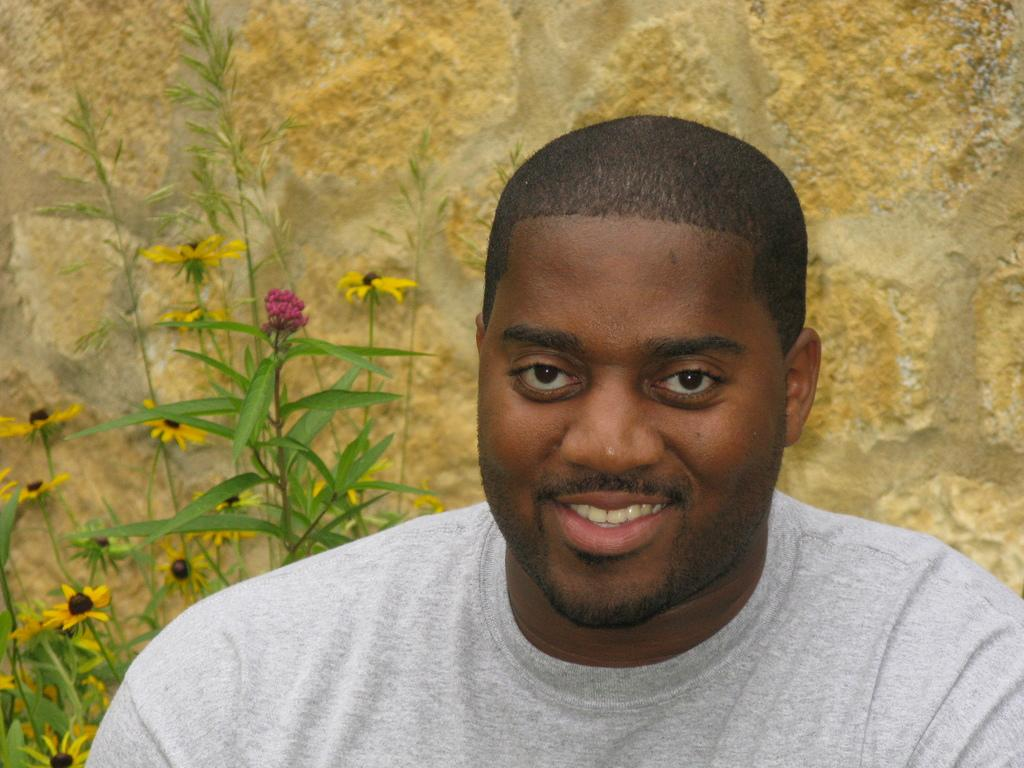Who is present in the image? There is a man in the image. What is the man doing in the image? The man is smiling in the image. What is the man wearing in the image? The man is wearing an ash-colored t-shirt in the image. What can be seen on the left side of the image? There are flower plants on the left side of the image. What is behind the man in the image? There is a stone wall behind the man in the image. How many stamps are visible on the man's t-shirt in the image? There are no stamps visible on the man's t-shirt in the image. What type of support is the man using to stand in the image? The image does not show the man using any support to stand; he is standing on his own. 